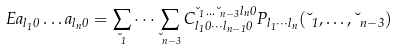<formula> <loc_0><loc_0><loc_500><loc_500>E a _ { l _ { 1 } 0 } \dots a _ { l _ { n } 0 } = \sum _ { \lambda _ { 1 } } \dots \sum _ { \lambda _ { n - 3 } } C _ { l _ { 1 } 0 \cdots l _ { n - 1 } 0 } ^ { \lambda _ { 1 } \dots \lambda _ { n - 3 } l _ { n } 0 } P _ { l _ { 1 } \cdots l _ { n } } ( \lambda _ { 1 } , \dots , \lambda _ { n - 3 } )</formula> 